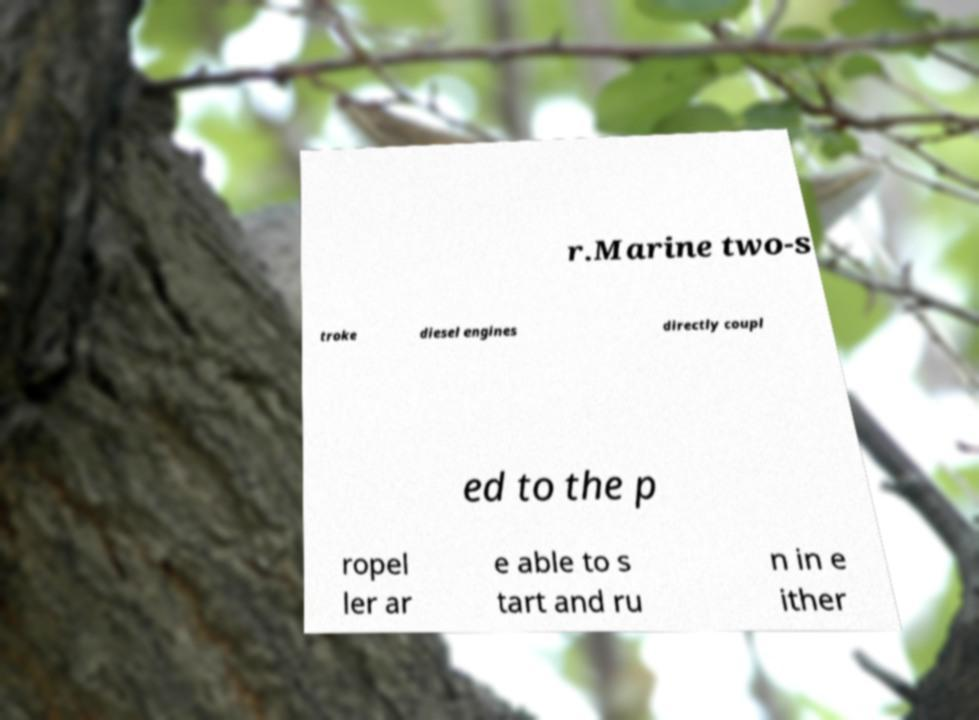For documentation purposes, I need the text within this image transcribed. Could you provide that? r.Marine two-s troke diesel engines directly coupl ed to the p ropel ler ar e able to s tart and ru n in e ither 